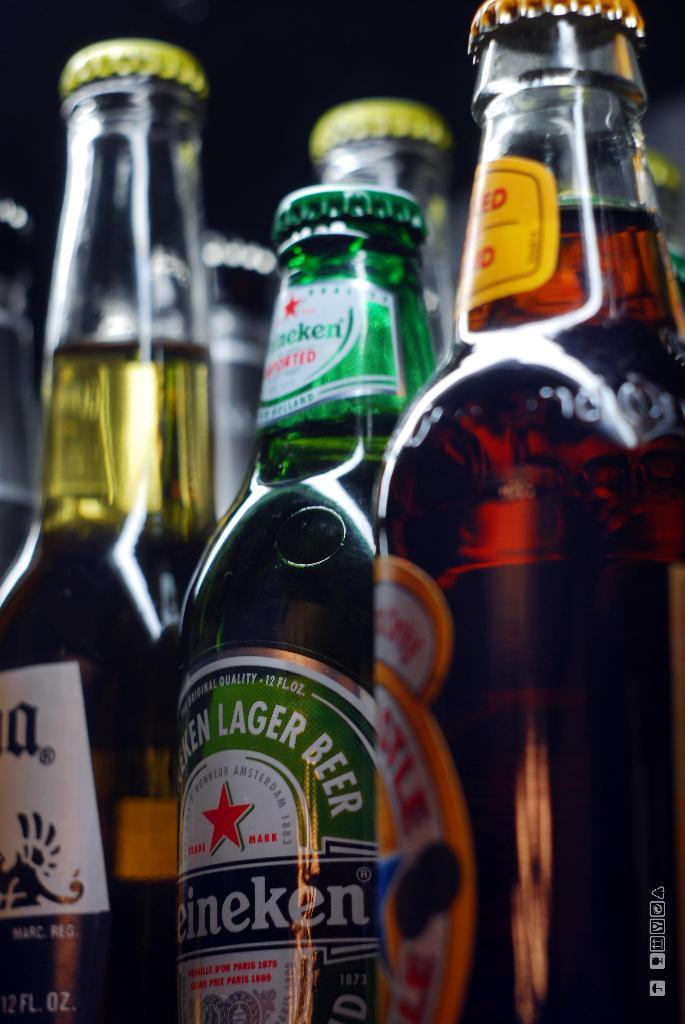What type of beverage containers are present in the image? There are wine bottles in the image. What type of insects can be seen crawling on the wine bottles in the image? There are no insects, including ants, present on the wine bottles in the image. 